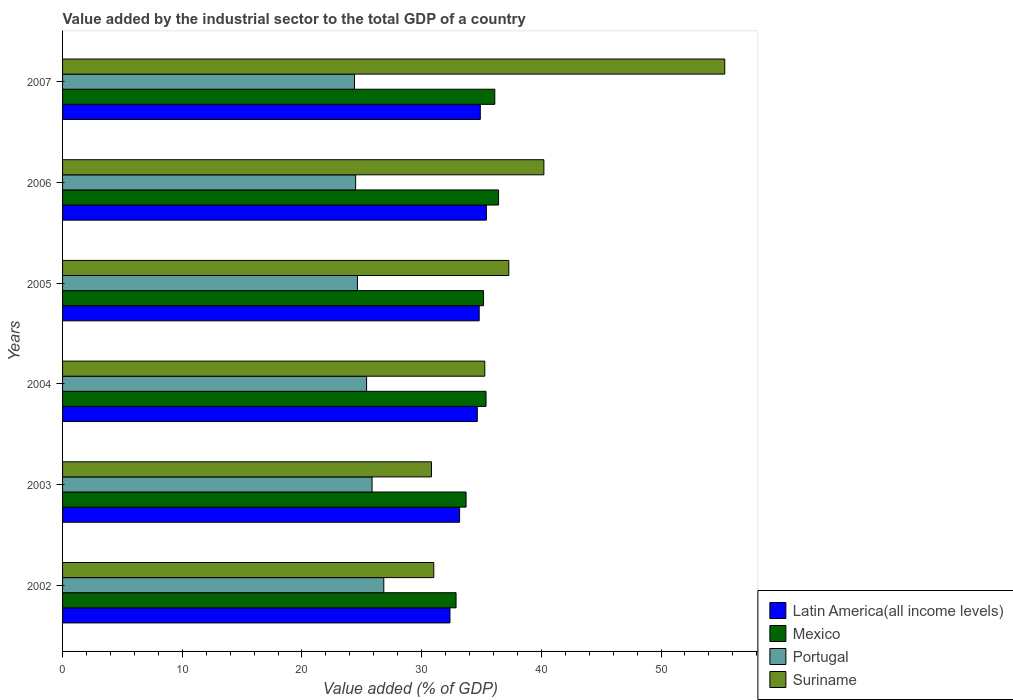How many groups of bars are there?
Your answer should be compact. 6. Are the number of bars on each tick of the Y-axis equal?
Your response must be concise. Yes. In how many cases, is the number of bars for a given year not equal to the number of legend labels?
Make the answer very short. 0. What is the value added by the industrial sector to the total GDP in Mexico in 2005?
Make the answer very short. 35.17. Across all years, what is the maximum value added by the industrial sector to the total GDP in Mexico?
Give a very brief answer. 36.43. Across all years, what is the minimum value added by the industrial sector to the total GDP in Latin America(all income levels)?
Your answer should be very brief. 32.37. What is the total value added by the industrial sector to the total GDP in Mexico in the graph?
Your answer should be very brief. 209.68. What is the difference between the value added by the industrial sector to the total GDP in Mexico in 2004 and that in 2005?
Your answer should be very brief. 0.21. What is the difference between the value added by the industrial sector to the total GDP in Suriname in 2004 and the value added by the industrial sector to the total GDP in Mexico in 2006?
Offer a terse response. -1.15. What is the average value added by the industrial sector to the total GDP in Latin America(all income levels) per year?
Provide a short and direct response. 34.22. In the year 2006, what is the difference between the value added by the industrial sector to the total GDP in Latin America(all income levels) and value added by the industrial sector to the total GDP in Suriname?
Keep it short and to the point. -4.8. In how many years, is the value added by the industrial sector to the total GDP in Latin America(all income levels) greater than 54 %?
Offer a very short reply. 0. What is the ratio of the value added by the industrial sector to the total GDP in Latin America(all income levels) in 2005 to that in 2007?
Your answer should be compact. 1. Is the value added by the industrial sector to the total GDP in Portugal in 2002 less than that in 2007?
Offer a terse response. No. Is the difference between the value added by the industrial sector to the total GDP in Latin America(all income levels) in 2006 and 2007 greater than the difference between the value added by the industrial sector to the total GDP in Suriname in 2006 and 2007?
Make the answer very short. Yes. What is the difference between the highest and the second highest value added by the industrial sector to the total GDP in Mexico?
Give a very brief answer. 0.32. What is the difference between the highest and the lowest value added by the industrial sector to the total GDP in Latin America(all income levels)?
Your answer should be compact. 3.04. Is the sum of the value added by the industrial sector to the total GDP in Portugal in 2005 and 2007 greater than the maximum value added by the industrial sector to the total GDP in Mexico across all years?
Provide a short and direct response. Yes. Is it the case that in every year, the sum of the value added by the industrial sector to the total GDP in Portugal and value added by the industrial sector to the total GDP in Latin America(all income levels) is greater than the sum of value added by the industrial sector to the total GDP in Mexico and value added by the industrial sector to the total GDP in Suriname?
Offer a very short reply. No. What does the 2nd bar from the top in 2003 represents?
Give a very brief answer. Portugal. What does the 4th bar from the bottom in 2004 represents?
Your answer should be very brief. Suriname. Are all the bars in the graph horizontal?
Make the answer very short. Yes. How many years are there in the graph?
Provide a short and direct response. 6. Are the values on the major ticks of X-axis written in scientific E-notation?
Make the answer very short. No. Does the graph contain grids?
Keep it short and to the point. No. How are the legend labels stacked?
Your answer should be compact. Vertical. What is the title of the graph?
Keep it short and to the point. Value added by the industrial sector to the total GDP of a country. What is the label or title of the X-axis?
Your answer should be compact. Value added (% of GDP). What is the label or title of the Y-axis?
Ensure brevity in your answer.  Years. What is the Value added (% of GDP) of Latin America(all income levels) in 2002?
Offer a very short reply. 32.37. What is the Value added (% of GDP) in Mexico in 2002?
Keep it short and to the point. 32.88. What is the Value added (% of GDP) of Portugal in 2002?
Provide a succinct answer. 26.84. What is the Value added (% of GDP) in Suriname in 2002?
Offer a terse response. 31.01. What is the Value added (% of GDP) in Latin America(all income levels) in 2003?
Make the answer very short. 33.17. What is the Value added (% of GDP) in Mexico in 2003?
Your answer should be compact. 33.71. What is the Value added (% of GDP) in Portugal in 2003?
Provide a short and direct response. 25.86. What is the Value added (% of GDP) of Suriname in 2003?
Give a very brief answer. 30.82. What is the Value added (% of GDP) of Latin America(all income levels) in 2004?
Make the answer very short. 34.65. What is the Value added (% of GDP) in Mexico in 2004?
Make the answer very short. 35.38. What is the Value added (% of GDP) of Portugal in 2004?
Make the answer very short. 25.4. What is the Value added (% of GDP) of Suriname in 2004?
Keep it short and to the point. 35.28. What is the Value added (% of GDP) of Latin America(all income levels) in 2005?
Give a very brief answer. 34.81. What is the Value added (% of GDP) of Mexico in 2005?
Your response must be concise. 35.17. What is the Value added (% of GDP) in Portugal in 2005?
Ensure brevity in your answer.  24.64. What is the Value added (% of GDP) of Suriname in 2005?
Offer a very short reply. 37.28. What is the Value added (% of GDP) in Latin America(all income levels) in 2006?
Your answer should be very brief. 35.41. What is the Value added (% of GDP) of Mexico in 2006?
Your response must be concise. 36.43. What is the Value added (% of GDP) of Portugal in 2006?
Your answer should be compact. 24.49. What is the Value added (% of GDP) of Suriname in 2006?
Ensure brevity in your answer.  40.21. What is the Value added (% of GDP) in Latin America(all income levels) in 2007?
Keep it short and to the point. 34.9. What is the Value added (% of GDP) in Mexico in 2007?
Keep it short and to the point. 36.11. What is the Value added (% of GDP) in Portugal in 2007?
Your answer should be compact. 24.39. What is the Value added (% of GDP) in Suriname in 2007?
Offer a very short reply. 55.33. Across all years, what is the maximum Value added (% of GDP) of Latin America(all income levels)?
Make the answer very short. 35.41. Across all years, what is the maximum Value added (% of GDP) of Mexico?
Make the answer very short. 36.43. Across all years, what is the maximum Value added (% of GDP) of Portugal?
Offer a terse response. 26.84. Across all years, what is the maximum Value added (% of GDP) of Suriname?
Your answer should be compact. 55.33. Across all years, what is the minimum Value added (% of GDP) of Latin America(all income levels)?
Give a very brief answer. 32.37. Across all years, what is the minimum Value added (% of GDP) of Mexico?
Make the answer very short. 32.88. Across all years, what is the minimum Value added (% of GDP) of Portugal?
Offer a very short reply. 24.39. Across all years, what is the minimum Value added (% of GDP) of Suriname?
Keep it short and to the point. 30.82. What is the total Value added (% of GDP) of Latin America(all income levels) in the graph?
Make the answer very short. 205.31. What is the total Value added (% of GDP) of Mexico in the graph?
Give a very brief answer. 209.68. What is the total Value added (% of GDP) in Portugal in the graph?
Your answer should be very brief. 151.61. What is the total Value added (% of GDP) of Suriname in the graph?
Make the answer very short. 229.94. What is the difference between the Value added (% of GDP) of Latin America(all income levels) in 2002 and that in 2003?
Make the answer very short. -0.81. What is the difference between the Value added (% of GDP) of Mexico in 2002 and that in 2003?
Offer a very short reply. -0.84. What is the difference between the Value added (% of GDP) in Portugal in 2002 and that in 2003?
Provide a short and direct response. 0.98. What is the difference between the Value added (% of GDP) in Suriname in 2002 and that in 2003?
Ensure brevity in your answer.  0.19. What is the difference between the Value added (% of GDP) in Latin America(all income levels) in 2002 and that in 2004?
Provide a succinct answer. -2.28. What is the difference between the Value added (% of GDP) in Mexico in 2002 and that in 2004?
Provide a succinct answer. -2.5. What is the difference between the Value added (% of GDP) of Portugal in 2002 and that in 2004?
Your answer should be very brief. 1.44. What is the difference between the Value added (% of GDP) of Suriname in 2002 and that in 2004?
Your answer should be compact. -4.26. What is the difference between the Value added (% of GDP) of Latin America(all income levels) in 2002 and that in 2005?
Ensure brevity in your answer.  -2.44. What is the difference between the Value added (% of GDP) in Mexico in 2002 and that in 2005?
Make the answer very short. -2.3. What is the difference between the Value added (% of GDP) in Portugal in 2002 and that in 2005?
Offer a very short reply. 2.2. What is the difference between the Value added (% of GDP) in Suriname in 2002 and that in 2005?
Keep it short and to the point. -6.27. What is the difference between the Value added (% of GDP) in Latin America(all income levels) in 2002 and that in 2006?
Keep it short and to the point. -3.04. What is the difference between the Value added (% of GDP) in Mexico in 2002 and that in 2006?
Give a very brief answer. -3.55. What is the difference between the Value added (% of GDP) in Portugal in 2002 and that in 2006?
Offer a terse response. 2.35. What is the difference between the Value added (% of GDP) of Suriname in 2002 and that in 2006?
Keep it short and to the point. -9.2. What is the difference between the Value added (% of GDP) of Latin America(all income levels) in 2002 and that in 2007?
Offer a terse response. -2.54. What is the difference between the Value added (% of GDP) in Mexico in 2002 and that in 2007?
Give a very brief answer. -3.24. What is the difference between the Value added (% of GDP) of Portugal in 2002 and that in 2007?
Provide a short and direct response. 2.45. What is the difference between the Value added (% of GDP) in Suriname in 2002 and that in 2007?
Provide a short and direct response. -24.31. What is the difference between the Value added (% of GDP) in Latin America(all income levels) in 2003 and that in 2004?
Provide a succinct answer. -1.48. What is the difference between the Value added (% of GDP) of Mexico in 2003 and that in 2004?
Make the answer very short. -1.67. What is the difference between the Value added (% of GDP) of Portugal in 2003 and that in 2004?
Make the answer very short. 0.46. What is the difference between the Value added (% of GDP) of Suriname in 2003 and that in 2004?
Provide a succinct answer. -4.45. What is the difference between the Value added (% of GDP) of Latin America(all income levels) in 2003 and that in 2005?
Provide a short and direct response. -1.64. What is the difference between the Value added (% of GDP) in Mexico in 2003 and that in 2005?
Your answer should be compact. -1.46. What is the difference between the Value added (% of GDP) of Portugal in 2003 and that in 2005?
Ensure brevity in your answer.  1.22. What is the difference between the Value added (% of GDP) in Suriname in 2003 and that in 2005?
Offer a very short reply. -6.46. What is the difference between the Value added (% of GDP) in Latin America(all income levels) in 2003 and that in 2006?
Make the answer very short. -2.24. What is the difference between the Value added (% of GDP) of Mexico in 2003 and that in 2006?
Keep it short and to the point. -2.72. What is the difference between the Value added (% of GDP) of Portugal in 2003 and that in 2006?
Make the answer very short. 1.37. What is the difference between the Value added (% of GDP) of Suriname in 2003 and that in 2006?
Ensure brevity in your answer.  -9.39. What is the difference between the Value added (% of GDP) in Latin America(all income levels) in 2003 and that in 2007?
Offer a very short reply. -1.73. What is the difference between the Value added (% of GDP) in Mexico in 2003 and that in 2007?
Your response must be concise. -2.4. What is the difference between the Value added (% of GDP) in Portugal in 2003 and that in 2007?
Give a very brief answer. 1.47. What is the difference between the Value added (% of GDP) in Suriname in 2003 and that in 2007?
Provide a short and direct response. -24.5. What is the difference between the Value added (% of GDP) in Latin America(all income levels) in 2004 and that in 2005?
Make the answer very short. -0.16. What is the difference between the Value added (% of GDP) in Mexico in 2004 and that in 2005?
Give a very brief answer. 0.21. What is the difference between the Value added (% of GDP) in Portugal in 2004 and that in 2005?
Keep it short and to the point. 0.76. What is the difference between the Value added (% of GDP) of Suriname in 2004 and that in 2005?
Give a very brief answer. -2.01. What is the difference between the Value added (% of GDP) of Latin America(all income levels) in 2004 and that in 2006?
Give a very brief answer. -0.76. What is the difference between the Value added (% of GDP) of Mexico in 2004 and that in 2006?
Provide a succinct answer. -1.05. What is the difference between the Value added (% of GDP) in Portugal in 2004 and that in 2006?
Provide a short and direct response. 0.92. What is the difference between the Value added (% of GDP) in Suriname in 2004 and that in 2006?
Offer a terse response. -4.94. What is the difference between the Value added (% of GDP) of Latin America(all income levels) in 2004 and that in 2007?
Make the answer very short. -0.25. What is the difference between the Value added (% of GDP) of Mexico in 2004 and that in 2007?
Provide a short and direct response. -0.73. What is the difference between the Value added (% of GDP) in Portugal in 2004 and that in 2007?
Ensure brevity in your answer.  1.01. What is the difference between the Value added (% of GDP) of Suriname in 2004 and that in 2007?
Your answer should be compact. -20.05. What is the difference between the Value added (% of GDP) in Latin America(all income levels) in 2005 and that in 2006?
Offer a terse response. -0.6. What is the difference between the Value added (% of GDP) in Mexico in 2005 and that in 2006?
Your answer should be compact. -1.26. What is the difference between the Value added (% of GDP) in Portugal in 2005 and that in 2006?
Keep it short and to the point. 0.15. What is the difference between the Value added (% of GDP) in Suriname in 2005 and that in 2006?
Provide a succinct answer. -2.93. What is the difference between the Value added (% of GDP) of Latin America(all income levels) in 2005 and that in 2007?
Make the answer very short. -0.09. What is the difference between the Value added (% of GDP) in Mexico in 2005 and that in 2007?
Offer a terse response. -0.94. What is the difference between the Value added (% of GDP) in Portugal in 2005 and that in 2007?
Ensure brevity in your answer.  0.25. What is the difference between the Value added (% of GDP) in Suriname in 2005 and that in 2007?
Provide a short and direct response. -18.04. What is the difference between the Value added (% of GDP) of Latin America(all income levels) in 2006 and that in 2007?
Ensure brevity in your answer.  0.51. What is the difference between the Value added (% of GDP) in Mexico in 2006 and that in 2007?
Provide a succinct answer. 0.32. What is the difference between the Value added (% of GDP) in Portugal in 2006 and that in 2007?
Offer a very short reply. 0.1. What is the difference between the Value added (% of GDP) of Suriname in 2006 and that in 2007?
Your answer should be very brief. -15.11. What is the difference between the Value added (% of GDP) in Latin America(all income levels) in 2002 and the Value added (% of GDP) in Mexico in 2003?
Provide a short and direct response. -1.35. What is the difference between the Value added (% of GDP) of Latin America(all income levels) in 2002 and the Value added (% of GDP) of Portugal in 2003?
Ensure brevity in your answer.  6.51. What is the difference between the Value added (% of GDP) of Latin America(all income levels) in 2002 and the Value added (% of GDP) of Suriname in 2003?
Provide a succinct answer. 1.55. What is the difference between the Value added (% of GDP) in Mexico in 2002 and the Value added (% of GDP) in Portugal in 2003?
Make the answer very short. 7.02. What is the difference between the Value added (% of GDP) in Mexico in 2002 and the Value added (% of GDP) in Suriname in 2003?
Ensure brevity in your answer.  2.05. What is the difference between the Value added (% of GDP) in Portugal in 2002 and the Value added (% of GDP) in Suriname in 2003?
Give a very brief answer. -3.98. What is the difference between the Value added (% of GDP) in Latin America(all income levels) in 2002 and the Value added (% of GDP) in Mexico in 2004?
Offer a terse response. -3.01. What is the difference between the Value added (% of GDP) in Latin America(all income levels) in 2002 and the Value added (% of GDP) in Portugal in 2004?
Your answer should be very brief. 6.97. What is the difference between the Value added (% of GDP) of Latin America(all income levels) in 2002 and the Value added (% of GDP) of Suriname in 2004?
Provide a short and direct response. -2.91. What is the difference between the Value added (% of GDP) in Mexico in 2002 and the Value added (% of GDP) in Portugal in 2004?
Offer a very short reply. 7.48. What is the difference between the Value added (% of GDP) in Mexico in 2002 and the Value added (% of GDP) in Suriname in 2004?
Keep it short and to the point. -2.4. What is the difference between the Value added (% of GDP) in Portugal in 2002 and the Value added (% of GDP) in Suriname in 2004?
Make the answer very short. -8.44. What is the difference between the Value added (% of GDP) in Latin America(all income levels) in 2002 and the Value added (% of GDP) in Mexico in 2005?
Your response must be concise. -2.81. What is the difference between the Value added (% of GDP) of Latin America(all income levels) in 2002 and the Value added (% of GDP) of Portugal in 2005?
Provide a succinct answer. 7.73. What is the difference between the Value added (% of GDP) in Latin America(all income levels) in 2002 and the Value added (% of GDP) in Suriname in 2005?
Provide a short and direct response. -4.92. What is the difference between the Value added (% of GDP) in Mexico in 2002 and the Value added (% of GDP) in Portugal in 2005?
Offer a very short reply. 8.24. What is the difference between the Value added (% of GDP) in Mexico in 2002 and the Value added (% of GDP) in Suriname in 2005?
Make the answer very short. -4.41. What is the difference between the Value added (% of GDP) in Portugal in 2002 and the Value added (% of GDP) in Suriname in 2005?
Provide a short and direct response. -10.44. What is the difference between the Value added (% of GDP) of Latin America(all income levels) in 2002 and the Value added (% of GDP) of Mexico in 2006?
Provide a succinct answer. -4.06. What is the difference between the Value added (% of GDP) in Latin America(all income levels) in 2002 and the Value added (% of GDP) in Portugal in 2006?
Keep it short and to the point. 7.88. What is the difference between the Value added (% of GDP) of Latin America(all income levels) in 2002 and the Value added (% of GDP) of Suriname in 2006?
Your answer should be compact. -7.85. What is the difference between the Value added (% of GDP) of Mexico in 2002 and the Value added (% of GDP) of Portugal in 2006?
Provide a succinct answer. 8.39. What is the difference between the Value added (% of GDP) in Mexico in 2002 and the Value added (% of GDP) in Suriname in 2006?
Make the answer very short. -7.34. What is the difference between the Value added (% of GDP) of Portugal in 2002 and the Value added (% of GDP) of Suriname in 2006?
Your response must be concise. -13.37. What is the difference between the Value added (% of GDP) in Latin America(all income levels) in 2002 and the Value added (% of GDP) in Mexico in 2007?
Make the answer very short. -3.75. What is the difference between the Value added (% of GDP) in Latin America(all income levels) in 2002 and the Value added (% of GDP) in Portugal in 2007?
Ensure brevity in your answer.  7.98. What is the difference between the Value added (% of GDP) in Latin America(all income levels) in 2002 and the Value added (% of GDP) in Suriname in 2007?
Keep it short and to the point. -22.96. What is the difference between the Value added (% of GDP) in Mexico in 2002 and the Value added (% of GDP) in Portugal in 2007?
Ensure brevity in your answer.  8.49. What is the difference between the Value added (% of GDP) in Mexico in 2002 and the Value added (% of GDP) in Suriname in 2007?
Ensure brevity in your answer.  -22.45. What is the difference between the Value added (% of GDP) of Portugal in 2002 and the Value added (% of GDP) of Suriname in 2007?
Provide a short and direct response. -28.49. What is the difference between the Value added (% of GDP) of Latin America(all income levels) in 2003 and the Value added (% of GDP) of Mexico in 2004?
Your response must be concise. -2.21. What is the difference between the Value added (% of GDP) in Latin America(all income levels) in 2003 and the Value added (% of GDP) in Portugal in 2004?
Make the answer very short. 7.77. What is the difference between the Value added (% of GDP) in Latin America(all income levels) in 2003 and the Value added (% of GDP) in Suriname in 2004?
Provide a succinct answer. -2.1. What is the difference between the Value added (% of GDP) in Mexico in 2003 and the Value added (% of GDP) in Portugal in 2004?
Your response must be concise. 8.31. What is the difference between the Value added (% of GDP) of Mexico in 2003 and the Value added (% of GDP) of Suriname in 2004?
Offer a very short reply. -1.56. What is the difference between the Value added (% of GDP) in Portugal in 2003 and the Value added (% of GDP) in Suriname in 2004?
Ensure brevity in your answer.  -9.42. What is the difference between the Value added (% of GDP) in Latin America(all income levels) in 2003 and the Value added (% of GDP) in Mexico in 2005?
Your answer should be very brief. -2. What is the difference between the Value added (% of GDP) of Latin America(all income levels) in 2003 and the Value added (% of GDP) of Portugal in 2005?
Your answer should be compact. 8.54. What is the difference between the Value added (% of GDP) in Latin America(all income levels) in 2003 and the Value added (% of GDP) in Suriname in 2005?
Give a very brief answer. -4.11. What is the difference between the Value added (% of GDP) of Mexico in 2003 and the Value added (% of GDP) of Portugal in 2005?
Offer a terse response. 9.08. What is the difference between the Value added (% of GDP) in Mexico in 2003 and the Value added (% of GDP) in Suriname in 2005?
Keep it short and to the point. -3.57. What is the difference between the Value added (% of GDP) in Portugal in 2003 and the Value added (% of GDP) in Suriname in 2005?
Offer a terse response. -11.43. What is the difference between the Value added (% of GDP) of Latin America(all income levels) in 2003 and the Value added (% of GDP) of Mexico in 2006?
Ensure brevity in your answer.  -3.26. What is the difference between the Value added (% of GDP) in Latin America(all income levels) in 2003 and the Value added (% of GDP) in Portugal in 2006?
Offer a terse response. 8.69. What is the difference between the Value added (% of GDP) in Latin America(all income levels) in 2003 and the Value added (% of GDP) in Suriname in 2006?
Your answer should be very brief. -7.04. What is the difference between the Value added (% of GDP) of Mexico in 2003 and the Value added (% of GDP) of Portugal in 2006?
Provide a succinct answer. 9.23. What is the difference between the Value added (% of GDP) of Mexico in 2003 and the Value added (% of GDP) of Suriname in 2006?
Ensure brevity in your answer.  -6.5. What is the difference between the Value added (% of GDP) of Portugal in 2003 and the Value added (% of GDP) of Suriname in 2006?
Offer a terse response. -14.36. What is the difference between the Value added (% of GDP) of Latin America(all income levels) in 2003 and the Value added (% of GDP) of Mexico in 2007?
Offer a terse response. -2.94. What is the difference between the Value added (% of GDP) in Latin America(all income levels) in 2003 and the Value added (% of GDP) in Portugal in 2007?
Offer a very short reply. 8.78. What is the difference between the Value added (% of GDP) in Latin America(all income levels) in 2003 and the Value added (% of GDP) in Suriname in 2007?
Your response must be concise. -22.15. What is the difference between the Value added (% of GDP) in Mexico in 2003 and the Value added (% of GDP) in Portugal in 2007?
Offer a terse response. 9.32. What is the difference between the Value added (% of GDP) in Mexico in 2003 and the Value added (% of GDP) in Suriname in 2007?
Make the answer very short. -21.61. What is the difference between the Value added (% of GDP) in Portugal in 2003 and the Value added (% of GDP) in Suriname in 2007?
Ensure brevity in your answer.  -29.47. What is the difference between the Value added (% of GDP) of Latin America(all income levels) in 2004 and the Value added (% of GDP) of Mexico in 2005?
Provide a short and direct response. -0.52. What is the difference between the Value added (% of GDP) in Latin America(all income levels) in 2004 and the Value added (% of GDP) in Portugal in 2005?
Give a very brief answer. 10.02. What is the difference between the Value added (% of GDP) in Latin America(all income levels) in 2004 and the Value added (% of GDP) in Suriname in 2005?
Offer a very short reply. -2.63. What is the difference between the Value added (% of GDP) in Mexico in 2004 and the Value added (% of GDP) in Portugal in 2005?
Keep it short and to the point. 10.74. What is the difference between the Value added (% of GDP) of Mexico in 2004 and the Value added (% of GDP) of Suriname in 2005?
Your answer should be compact. -1.9. What is the difference between the Value added (% of GDP) in Portugal in 2004 and the Value added (% of GDP) in Suriname in 2005?
Make the answer very short. -11.88. What is the difference between the Value added (% of GDP) in Latin America(all income levels) in 2004 and the Value added (% of GDP) in Mexico in 2006?
Your response must be concise. -1.78. What is the difference between the Value added (% of GDP) in Latin America(all income levels) in 2004 and the Value added (% of GDP) in Portugal in 2006?
Make the answer very short. 10.17. What is the difference between the Value added (% of GDP) of Latin America(all income levels) in 2004 and the Value added (% of GDP) of Suriname in 2006?
Your response must be concise. -5.56. What is the difference between the Value added (% of GDP) in Mexico in 2004 and the Value added (% of GDP) in Portugal in 2006?
Ensure brevity in your answer.  10.89. What is the difference between the Value added (% of GDP) of Mexico in 2004 and the Value added (% of GDP) of Suriname in 2006?
Your answer should be compact. -4.83. What is the difference between the Value added (% of GDP) in Portugal in 2004 and the Value added (% of GDP) in Suriname in 2006?
Give a very brief answer. -14.81. What is the difference between the Value added (% of GDP) in Latin America(all income levels) in 2004 and the Value added (% of GDP) in Mexico in 2007?
Provide a succinct answer. -1.46. What is the difference between the Value added (% of GDP) in Latin America(all income levels) in 2004 and the Value added (% of GDP) in Portugal in 2007?
Your answer should be very brief. 10.26. What is the difference between the Value added (% of GDP) of Latin America(all income levels) in 2004 and the Value added (% of GDP) of Suriname in 2007?
Your answer should be very brief. -20.67. What is the difference between the Value added (% of GDP) of Mexico in 2004 and the Value added (% of GDP) of Portugal in 2007?
Provide a succinct answer. 10.99. What is the difference between the Value added (% of GDP) of Mexico in 2004 and the Value added (% of GDP) of Suriname in 2007?
Provide a short and direct response. -19.95. What is the difference between the Value added (% of GDP) in Portugal in 2004 and the Value added (% of GDP) in Suriname in 2007?
Offer a very short reply. -29.93. What is the difference between the Value added (% of GDP) in Latin America(all income levels) in 2005 and the Value added (% of GDP) in Mexico in 2006?
Give a very brief answer. -1.62. What is the difference between the Value added (% of GDP) of Latin America(all income levels) in 2005 and the Value added (% of GDP) of Portugal in 2006?
Ensure brevity in your answer.  10.32. What is the difference between the Value added (% of GDP) of Latin America(all income levels) in 2005 and the Value added (% of GDP) of Suriname in 2006?
Ensure brevity in your answer.  -5.41. What is the difference between the Value added (% of GDP) in Mexico in 2005 and the Value added (% of GDP) in Portugal in 2006?
Your answer should be very brief. 10.69. What is the difference between the Value added (% of GDP) in Mexico in 2005 and the Value added (% of GDP) in Suriname in 2006?
Keep it short and to the point. -5.04. What is the difference between the Value added (% of GDP) in Portugal in 2005 and the Value added (% of GDP) in Suriname in 2006?
Offer a very short reply. -15.58. What is the difference between the Value added (% of GDP) of Latin America(all income levels) in 2005 and the Value added (% of GDP) of Mexico in 2007?
Offer a very short reply. -1.3. What is the difference between the Value added (% of GDP) of Latin America(all income levels) in 2005 and the Value added (% of GDP) of Portugal in 2007?
Keep it short and to the point. 10.42. What is the difference between the Value added (% of GDP) of Latin America(all income levels) in 2005 and the Value added (% of GDP) of Suriname in 2007?
Your response must be concise. -20.52. What is the difference between the Value added (% of GDP) in Mexico in 2005 and the Value added (% of GDP) in Portugal in 2007?
Provide a succinct answer. 10.78. What is the difference between the Value added (% of GDP) in Mexico in 2005 and the Value added (% of GDP) in Suriname in 2007?
Give a very brief answer. -20.15. What is the difference between the Value added (% of GDP) of Portugal in 2005 and the Value added (% of GDP) of Suriname in 2007?
Keep it short and to the point. -30.69. What is the difference between the Value added (% of GDP) of Latin America(all income levels) in 2006 and the Value added (% of GDP) of Mexico in 2007?
Provide a succinct answer. -0.7. What is the difference between the Value added (% of GDP) in Latin America(all income levels) in 2006 and the Value added (% of GDP) in Portugal in 2007?
Your answer should be very brief. 11.02. What is the difference between the Value added (% of GDP) of Latin America(all income levels) in 2006 and the Value added (% of GDP) of Suriname in 2007?
Provide a succinct answer. -19.92. What is the difference between the Value added (% of GDP) in Mexico in 2006 and the Value added (% of GDP) in Portugal in 2007?
Give a very brief answer. 12.04. What is the difference between the Value added (% of GDP) of Mexico in 2006 and the Value added (% of GDP) of Suriname in 2007?
Provide a succinct answer. -18.9. What is the difference between the Value added (% of GDP) of Portugal in 2006 and the Value added (% of GDP) of Suriname in 2007?
Offer a very short reply. -30.84. What is the average Value added (% of GDP) in Latin America(all income levels) per year?
Offer a very short reply. 34.22. What is the average Value added (% of GDP) in Mexico per year?
Your response must be concise. 34.95. What is the average Value added (% of GDP) in Portugal per year?
Give a very brief answer. 25.27. What is the average Value added (% of GDP) of Suriname per year?
Provide a short and direct response. 38.32. In the year 2002, what is the difference between the Value added (% of GDP) in Latin America(all income levels) and Value added (% of GDP) in Mexico?
Your answer should be compact. -0.51. In the year 2002, what is the difference between the Value added (% of GDP) of Latin America(all income levels) and Value added (% of GDP) of Portugal?
Offer a very short reply. 5.53. In the year 2002, what is the difference between the Value added (% of GDP) of Latin America(all income levels) and Value added (% of GDP) of Suriname?
Your answer should be very brief. 1.35. In the year 2002, what is the difference between the Value added (% of GDP) of Mexico and Value added (% of GDP) of Portugal?
Your response must be concise. 6.04. In the year 2002, what is the difference between the Value added (% of GDP) in Mexico and Value added (% of GDP) in Suriname?
Provide a succinct answer. 1.86. In the year 2002, what is the difference between the Value added (% of GDP) of Portugal and Value added (% of GDP) of Suriname?
Give a very brief answer. -4.18. In the year 2003, what is the difference between the Value added (% of GDP) in Latin America(all income levels) and Value added (% of GDP) in Mexico?
Give a very brief answer. -0.54. In the year 2003, what is the difference between the Value added (% of GDP) in Latin America(all income levels) and Value added (% of GDP) in Portugal?
Your answer should be very brief. 7.31. In the year 2003, what is the difference between the Value added (% of GDP) of Latin America(all income levels) and Value added (% of GDP) of Suriname?
Give a very brief answer. 2.35. In the year 2003, what is the difference between the Value added (% of GDP) of Mexico and Value added (% of GDP) of Portugal?
Your answer should be very brief. 7.85. In the year 2003, what is the difference between the Value added (% of GDP) of Mexico and Value added (% of GDP) of Suriname?
Your answer should be compact. 2.89. In the year 2003, what is the difference between the Value added (% of GDP) in Portugal and Value added (% of GDP) in Suriname?
Make the answer very short. -4.96. In the year 2004, what is the difference between the Value added (% of GDP) of Latin America(all income levels) and Value added (% of GDP) of Mexico?
Provide a short and direct response. -0.73. In the year 2004, what is the difference between the Value added (% of GDP) of Latin America(all income levels) and Value added (% of GDP) of Portugal?
Offer a very short reply. 9.25. In the year 2004, what is the difference between the Value added (% of GDP) of Latin America(all income levels) and Value added (% of GDP) of Suriname?
Your answer should be very brief. -0.62. In the year 2004, what is the difference between the Value added (% of GDP) in Mexico and Value added (% of GDP) in Portugal?
Provide a short and direct response. 9.98. In the year 2004, what is the difference between the Value added (% of GDP) in Mexico and Value added (% of GDP) in Suriname?
Provide a succinct answer. 0.1. In the year 2004, what is the difference between the Value added (% of GDP) in Portugal and Value added (% of GDP) in Suriname?
Your answer should be compact. -9.87. In the year 2005, what is the difference between the Value added (% of GDP) in Latin America(all income levels) and Value added (% of GDP) in Mexico?
Provide a short and direct response. -0.36. In the year 2005, what is the difference between the Value added (% of GDP) in Latin America(all income levels) and Value added (% of GDP) in Portugal?
Make the answer very short. 10.17. In the year 2005, what is the difference between the Value added (% of GDP) in Latin America(all income levels) and Value added (% of GDP) in Suriname?
Offer a terse response. -2.48. In the year 2005, what is the difference between the Value added (% of GDP) in Mexico and Value added (% of GDP) in Portugal?
Keep it short and to the point. 10.54. In the year 2005, what is the difference between the Value added (% of GDP) in Mexico and Value added (% of GDP) in Suriname?
Provide a succinct answer. -2.11. In the year 2005, what is the difference between the Value added (% of GDP) in Portugal and Value added (% of GDP) in Suriname?
Provide a succinct answer. -12.65. In the year 2006, what is the difference between the Value added (% of GDP) in Latin America(all income levels) and Value added (% of GDP) in Mexico?
Offer a terse response. -1.02. In the year 2006, what is the difference between the Value added (% of GDP) of Latin America(all income levels) and Value added (% of GDP) of Portugal?
Your answer should be very brief. 10.92. In the year 2006, what is the difference between the Value added (% of GDP) in Latin America(all income levels) and Value added (% of GDP) in Suriname?
Keep it short and to the point. -4.8. In the year 2006, what is the difference between the Value added (% of GDP) of Mexico and Value added (% of GDP) of Portugal?
Ensure brevity in your answer.  11.94. In the year 2006, what is the difference between the Value added (% of GDP) of Mexico and Value added (% of GDP) of Suriname?
Offer a terse response. -3.78. In the year 2006, what is the difference between the Value added (% of GDP) in Portugal and Value added (% of GDP) in Suriname?
Offer a terse response. -15.73. In the year 2007, what is the difference between the Value added (% of GDP) of Latin America(all income levels) and Value added (% of GDP) of Mexico?
Make the answer very short. -1.21. In the year 2007, what is the difference between the Value added (% of GDP) in Latin America(all income levels) and Value added (% of GDP) in Portugal?
Provide a short and direct response. 10.51. In the year 2007, what is the difference between the Value added (% of GDP) of Latin America(all income levels) and Value added (% of GDP) of Suriname?
Your answer should be very brief. -20.42. In the year 2007, what is the difference between the Value added (% of GDP) of Mexico and Value added (% of GDP) of Portugal?
Ensure brevity in your answer.  11.72. In the year 2007, what is the difference between the Value added (% of GDP) of Mexico and Value added (% of GDP) of Suriname?
Give a very brief answer. -19.21. In the year 2007, what is the difference between the Value added (% of GDP) in Portugal and Value added (% of GDP) in Suriname?
Offer a terse response. -30.94. What is the ratio of the Value added (% of GDP) in Latin America(all income levels) in 2002 to that in 2003?
Give a very brief answer. 0.98. What is the ratio of the Value added (% of GDP) in Mexico in 2002 to that in 2003?
Make the answer very short. 0.98. What is the ratio of the Value added (% of GDP) in Portugal in 2002 to that in 2003?
Make the answer very short. 1.04. What is the ratio of the Value added (% of GDP) of Latin America(all income levels) in 2002 to that in 2004?
Make the answer very short. 0.93. What is the ratio of the Value added (% of GDP) of Mexico in 2002 to that in 2004?
Offer a terse response. 0.93. What is the ratio of the Value added (% of GDP) of Portugal in 2002 to that in 2004?
Make the answer very short. 1.06. What is the ratio of the Value added (% of GDP) of Suriname in 2002 to that in 2004?
Provide a short and direct response. 0.88. What is the ratio of the Value added (% of GDP) of Latin America(all income levels) in 2002 to that in 2005?
Keep it short and to the point. 0.93. What is the ratio of the Value added (% of GDP) of Mexico in 2002 to that in 2005?
Your answer should be compact. 0.93. What is the ratio of the Value added (% of GDP) in Portugal in 2002 to that in 2005?
Make the answer very short. 1.09. What is the ratio of the Value added (% of GDP) of Suriname in 2002 to that in 2005?
Offer a terse response. 0.83. What is the ratio of the Value added (% of GDP) of Latin America(all income levels) in 2002 to that in 2006?
Make the answer very short. 0.91. What is the ratio of the Value added (% of GDP) in Mexico in 2002 to that in 2006?
Offer a terse response. 0.9. What is the ratio of the Value added (% of GDP) of Portugal in 2002 to that in 2006?
Keep it short and to the point. 1.1. What is the ratio of the Value added (% of GDP) in Suriname in 2002 to that in 2006?
Make the answer very short. 0.77. What is the ratio of the Value added (% of GDP) in Latin America(all income levels) in 2002 to that in 2007?
Ensure brevity in your answer.  0.93. What is the ratio of the Value added (% of GDP) in Mexico in 2002 to that in 2007?
Your response must be concise. 0.91. What is the ratio of the Value added (% of GDP) of Portugal in 2002 to that in 2007?
Your answer should be very brief. 1.1. What is the ratio of the Value added (% of GDP) in Suriname in 2002 to that in 2007?
Give a very brief answer. 0.56. What is the ratio of the Value added (% of GDP) in Latin America(all income levels) in 2003 to that in 2004?
Offer a very short reply. 0.96. What is the ratio of the Value added (% of GDP) of Mexico in 2003 to that in 2004?
Keep it short and to the point. 0.95. What is the ratio of the Value added (% of GDP) in Portugal in 2003 to that in 2004?
Ensure brevity in your answer.  1.02. What is the ratio of the Value added (% of GDP) of Suriname in 2003 to that in 2004?
Offer a terse response. 0.87. What is the ratio of the Value added (% of GDP) of Latin America(all income levels) in 2003 to that in 2005?
Keep it short and to the point. 0.95. What is the ratio of the Value added (% of GDP) in Mexico in 2003 to that in 2005?
Offer a terse response. 0.96. What is the ratio of the Value added (% of GDP) in Portugal in 2003 to that in 2005?
Your answer should be compact. 1.05. What is the ratio of the Value added (% of GDP) in Suriname in 2003 to that in 2005?
Your answer should be very brief. 0.83. What is the ratio of the Value added (% of GDP) in Latin America(all income levels) in 2003 to that in 2006?
Your answer should be compact. 0.94. What is the ratio of the Value added (% of GDP) of Mexico in 2003 to that in 2006?
Provide a short and direct response. 0.93. What is the ratio of the Value added (% of GDP) in Portugal in 2003 to that in 2006?
Offer a terse response. 1.06. What is the ratio of the Value added (% of GDP) in Suriname in 2003 to that in 2006?
Your response must be concise. 0.77. What is the ratio of the Value added (% of GDP) in Latin America(all income levels) in 2003 to that in 2007?
Provide a short and direct response. 0.95. What is the ratio of the Value added (% of GDP) of Mexico in 2003 to that in 2007?
Your answer should be compact. 0.93. What is the ratio of the Value added (% of GDP) of Portugal in 2003 to that in 2007?
Give a very brief answer. 1.06. What is the ratio of the Value added (% of GDP) in Suriname in 2003 to that in 2007?
Offer a very short reply. 0.56. What is the ratio of the Value added (% of GDP) in Latin America(all income levels) in 2004 to that in 2005?
Give a very brief answer. 1. What is the ratio of the Value added (% of GDP) in Mexico in 2004 to that in 2005?
Offer a terse response. 1.01. What is the ratio of the Value added (% of GDP) in Portugal in 2004 to that in 2005?
Offer a very short reply. 1.03. What is the ratio of the Value added (% of GDP) in Suriname in 2004 to that in 2005?
Your answer should be very brief. 0.95. What is the ratio of the Value added (% of GDP) in Latin America(all income levels) in 2004 to that in 2006?
Keep it short and to the point. 0.98. What is the ratio of the Value added (% of GDP) of Mexico in 2004 to that in 2006?
Your answer should be compact. 0.97. What is the ratio of the Value added (% of GDP) in Portugal in 2004 to that in 2006?
Give a very brief answer. 1.04. What is the ratio of the Value added (% of GDP) in Suriname in 2004 to that in 2006?
Provide a short and direct response. 0.88. What is the ratio of the Value added (% of GDP) of Mexico in 2004 to that in 2007?
Keep it short and to the point. 0.98. What is the ratio of the Value added (% of GDP) in Portugal in 2004 to that in 2007?
Make the answer very short. 1.04. What is the ratio of the Value added (% of GDP) in Suriname in 2004 to that in 2007?
Offer a very short reply. 0.64. What is the ratio of the Value added (% of GDP) in Mexico in 2005 to that in 2006?
Your answer should be compact. 0.97. What is the ratio of the Value added (% of GDP) of Suriname in 2005 to that in 2006?
Offer a terse response. 0.93. What is the ratio of the Value added (% of GDP) of Latin America(all income levels) in 2005 to that in 2007?
Keep it short and to the point. 1. What is the ratio of the Value added (% of GDP) in Portugal in 2005 to that in 2007?
Offer a terse response. 1.01. What is the ratio of the Value added (% of GDP) of Suriname in 2005 to that in 2007?
Your response must be concise. 0.67. What is the ratio of the Value added (% of GDP) of Latin America(all income levels) in 2006 to that in 2007?
Your answer should be compact. 1.01. What is the ratio of the Value added (% of GDP) of Mexico in 2006 to that in 2007?
Offer a terse response. 1.01. What is the ratio of the Value added (% of GDP) of Suriname in 2006 to that in 2007?
Keep it short and to the point. 0.73. What is the difference between the highest and the second highest Value added (% of GDP) of Latin America(all income levels)?
Make the answer very short. 0.51. What is the difference between the highest and the second highest Value added (% of GDP) in Mexico?
Ensure brevity in your answer.  0.32. What is the difference between the highest and the second highest Value added (% of GDP) in Portugal?
Give a very brief answer. 0.98. What is the difference between the highest and the second highest Value added (% of GDP) of Suriname?
Offer a very short reply. 15.11. What is the difference between the highest and the lowest Value added (% of GDP) of Latin America(all income levels)?
Your answer should be very brief. 3.04. What is the difference between the highest and the lowest Value added (% of GDP) of Mexico?
Provide a short and direct response. 3.55. What is the difference between the highest and the lowest Value added (% of GDP) in Portugal?
Provide a short and direct response. 2.45. What is the difference between the highest and the lowest Value added (% of GDP) in Suriname?
Provide a succinct answer. 24.5. 